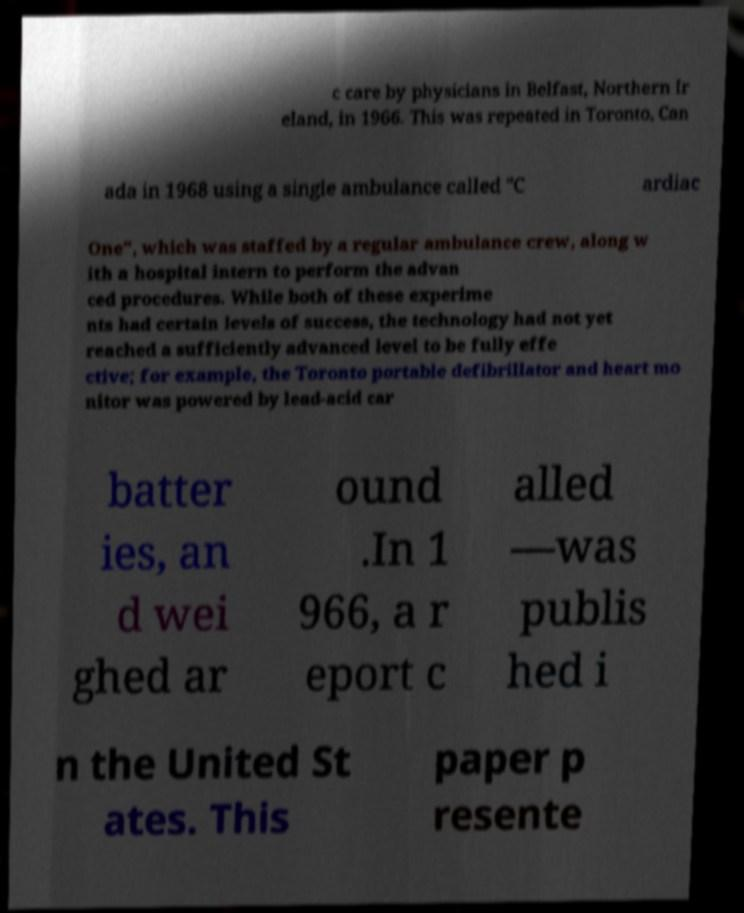Can you accurately transcribe the text from the provided image for me? c care by physicians in Belfast, Northern Ir eland, in 1966. This was repeated in Toronto, Can ada in 1968 using a single ambulance called "C ardiac One", which was staffed by a regular ambulance crew, along w ith a hospital intern to perform the advan ced procedures. While both of these experime nts had certain levels of success, the technology had not yet reached a sufficiently advanced level to be fully effe ctive; for example, the Toronto portable defibrillator and heart mo nitor was powered by lead-acid car batter ies, an d wei ghed ar ound .In 1 966, a r eport c alled —was publis hed i n the United St ates. This paper p resente 